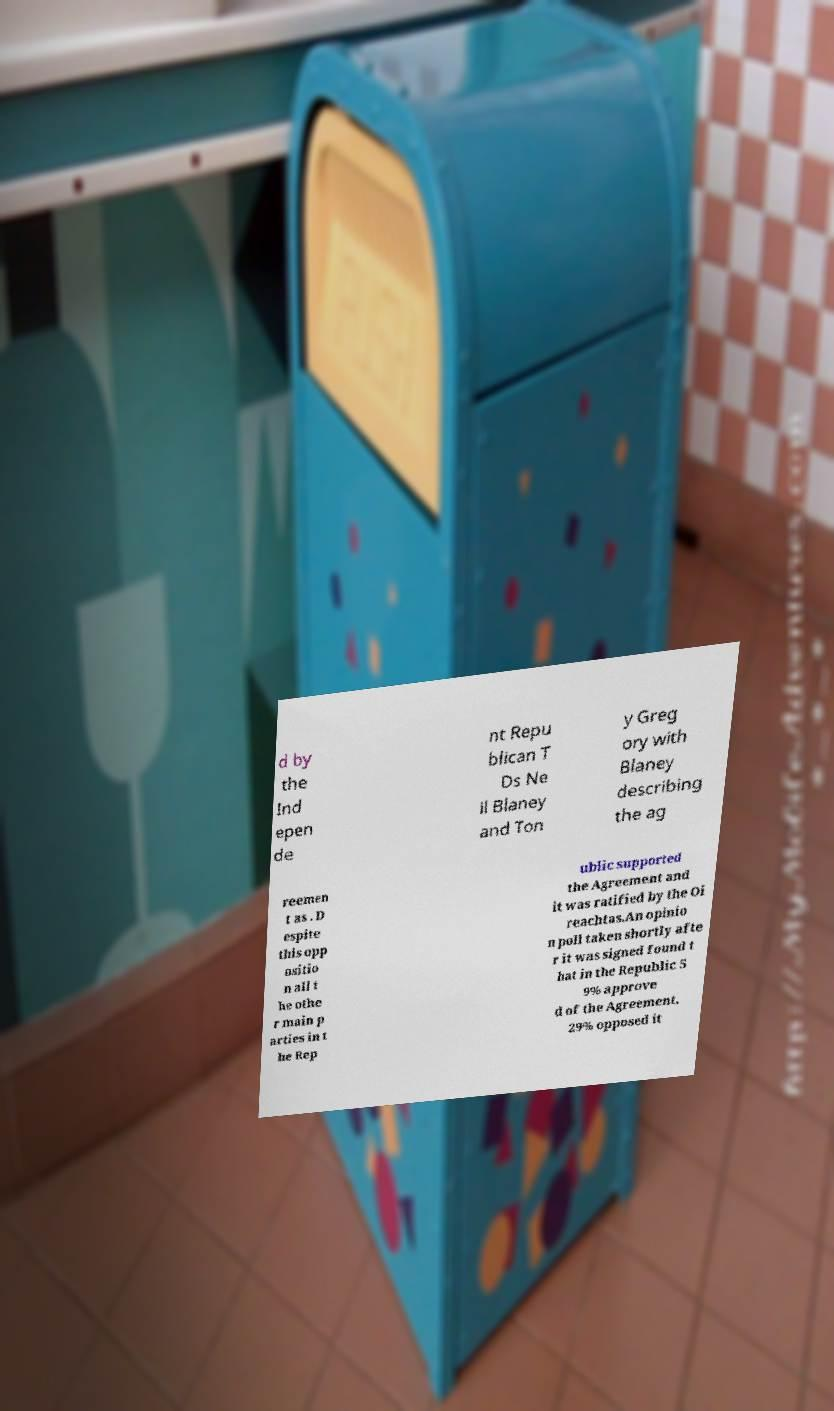I need the written content from this picture converted into text. Can you do that? d by the Ind epen de nt Repu blican T Ds Ne il Blaney and Ton y Greg ory with Blaney describing the ag reemen t as . D espite this opp ositio n all t he othe r main p arties in t he Rep ublic supported the Agreement and it was ratified by the Oi reachtas.An opinio n poll taken shortly afte r it was signed found t hat in the Republic 5 9% approve d of the Agreement, 29% opposed it 